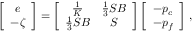<formula> <loc_0><loc_0><loc_500><loc_500>\left [ \begin{array} { c } { e } \\ { - \zeta } \end{array} \right ] = \left [ \begin{array} { c c c } { \frac { 1 } { K } } & { \frac { 1 } { 3 } S B } \\ { \frac { 1 } { 3 } S B } & { S } \end{array} \right ] \left [ \begin{array} { c } { - p _ { c } } \\ { - p _ { f } } \end{array} \right ] \, ,</formula> 